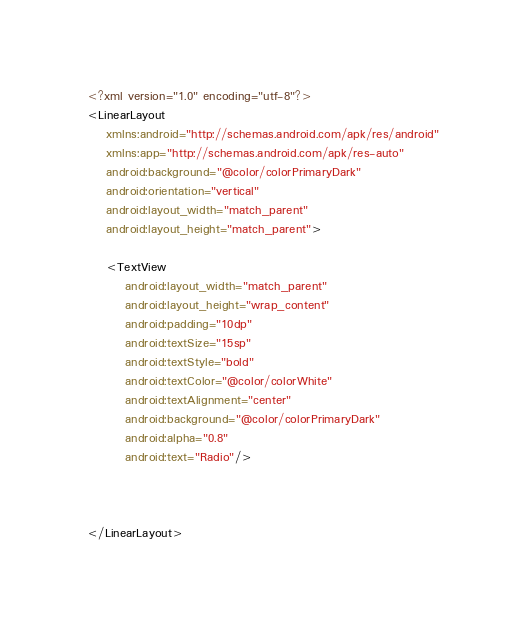Convert code to text. <code><loc_0><loc_0><loc_500><loc_500><_XML_><?xml version="1.0" encoding="utf-8"?>
<LinearLayout
    xmlns:android="http://schemas.android.com/apk/res/android"
    xmlns:app="http://schemas.android.com/apk/res-auto"
    android:background="@color/colorPrimaryDark"
    android:orientation="vertical"
    android:layout_width="match_parent"
    android:layout_height="match_parent">

    <TextView
        android:layout_width="match_parent"
        android:layout_height="wrap_content"
        android:padding="10dp"
        android:textSize="15sp"
        android:textStyle="bold"
        android:textColor="@color/colorWhite"
        android:textAlignment="center"
        android:background="@color/colorPrimaryDark"
        android:alpha="0.8"
        android:text="Radio"/>



</LinearLayout></code> 